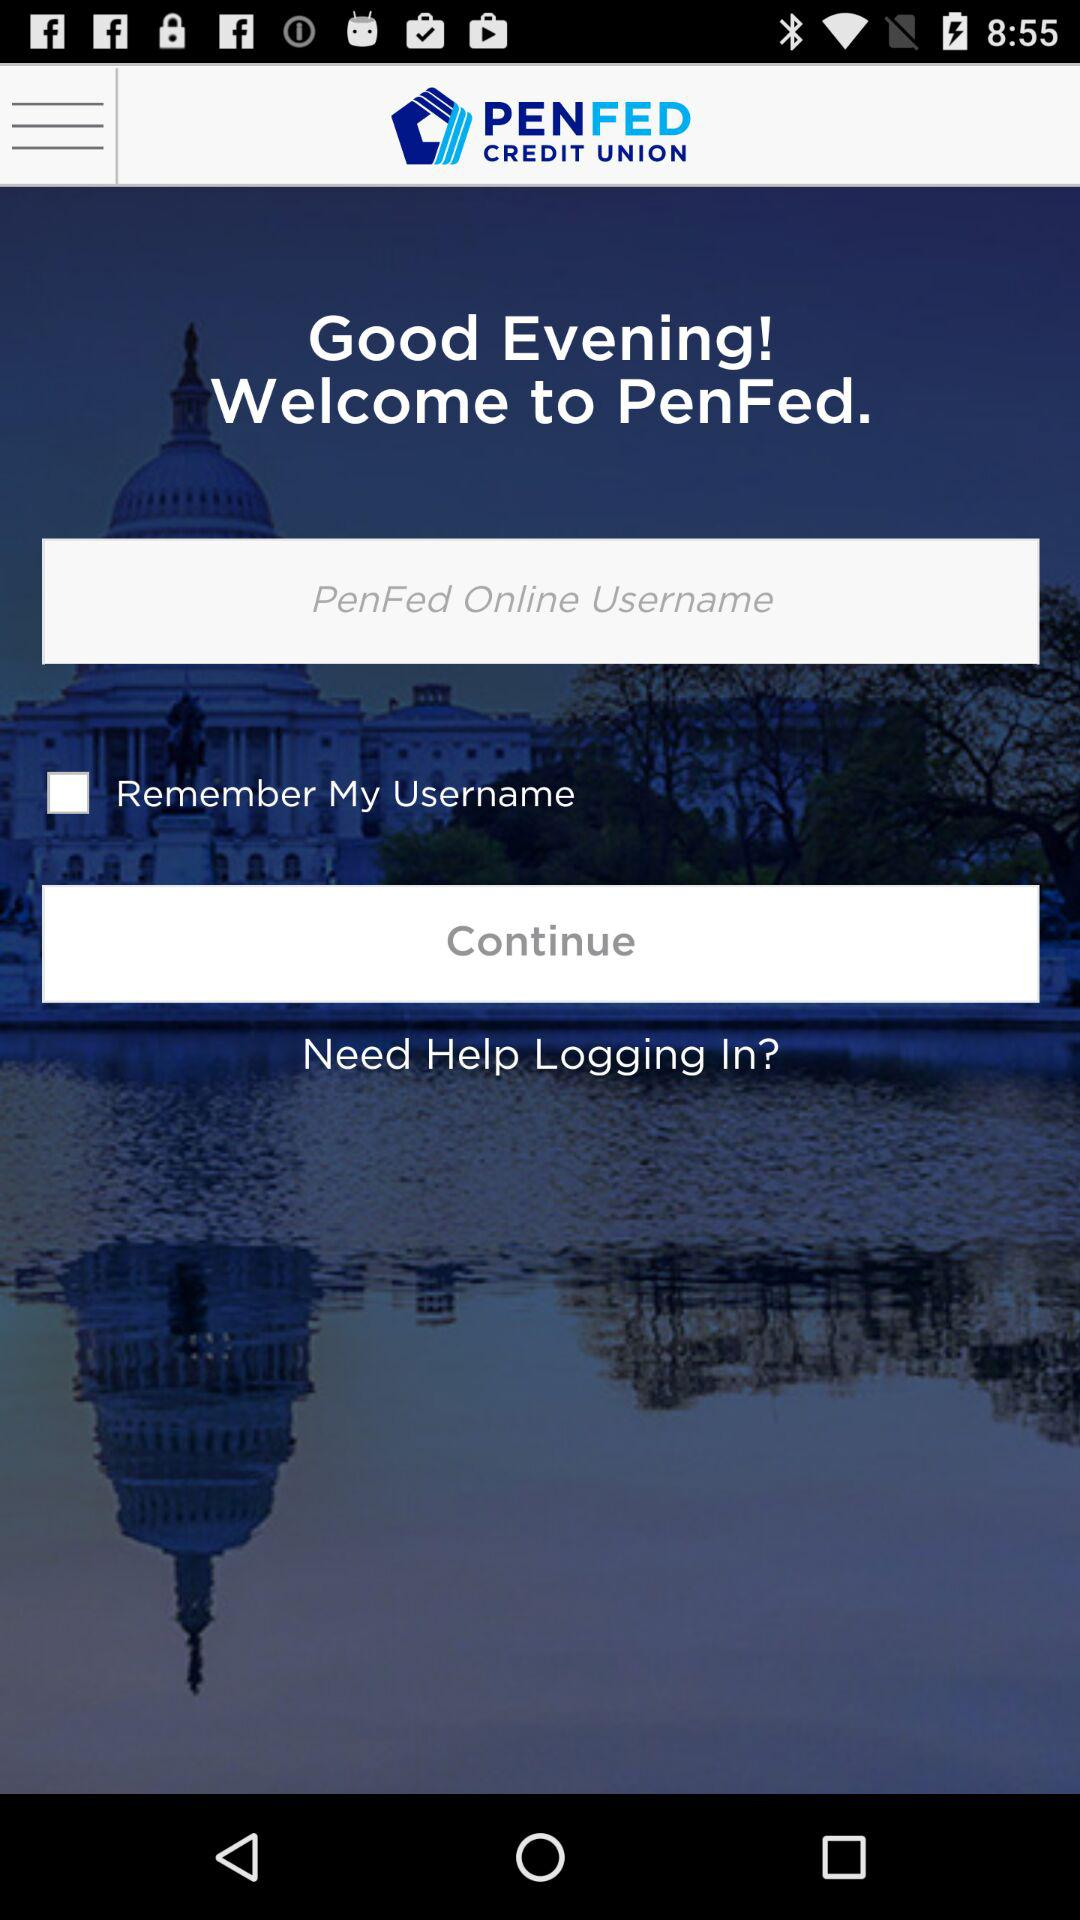What is the application name? The application name is "PENFED". 